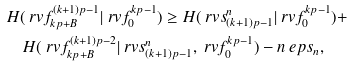<formula> <loc_0><loc_0><loc_500><loc_500>& H ( \ r v f _ { k p + B } ^ { ( k + 1 ) p - 1 } | \ r v f _ { 0 } ^ { k p - 1 } ) \geq H ( \ r v s _ { ( k + 1 ) p - 1 } ^ { n } | \ r v f _ { 0 } ^ { k p - 1 } ) + \\ & \quad H ( \ r v f _ { k p + B } ^ { ( k + 1 ) p - 2 } | \ r v s _ { ( k + 1 ) p - 1 } ^ { n } , \ r v f _ { 0 } ^ { k p - 1 } ) - n \ e p s _ { n } ,</formula> 